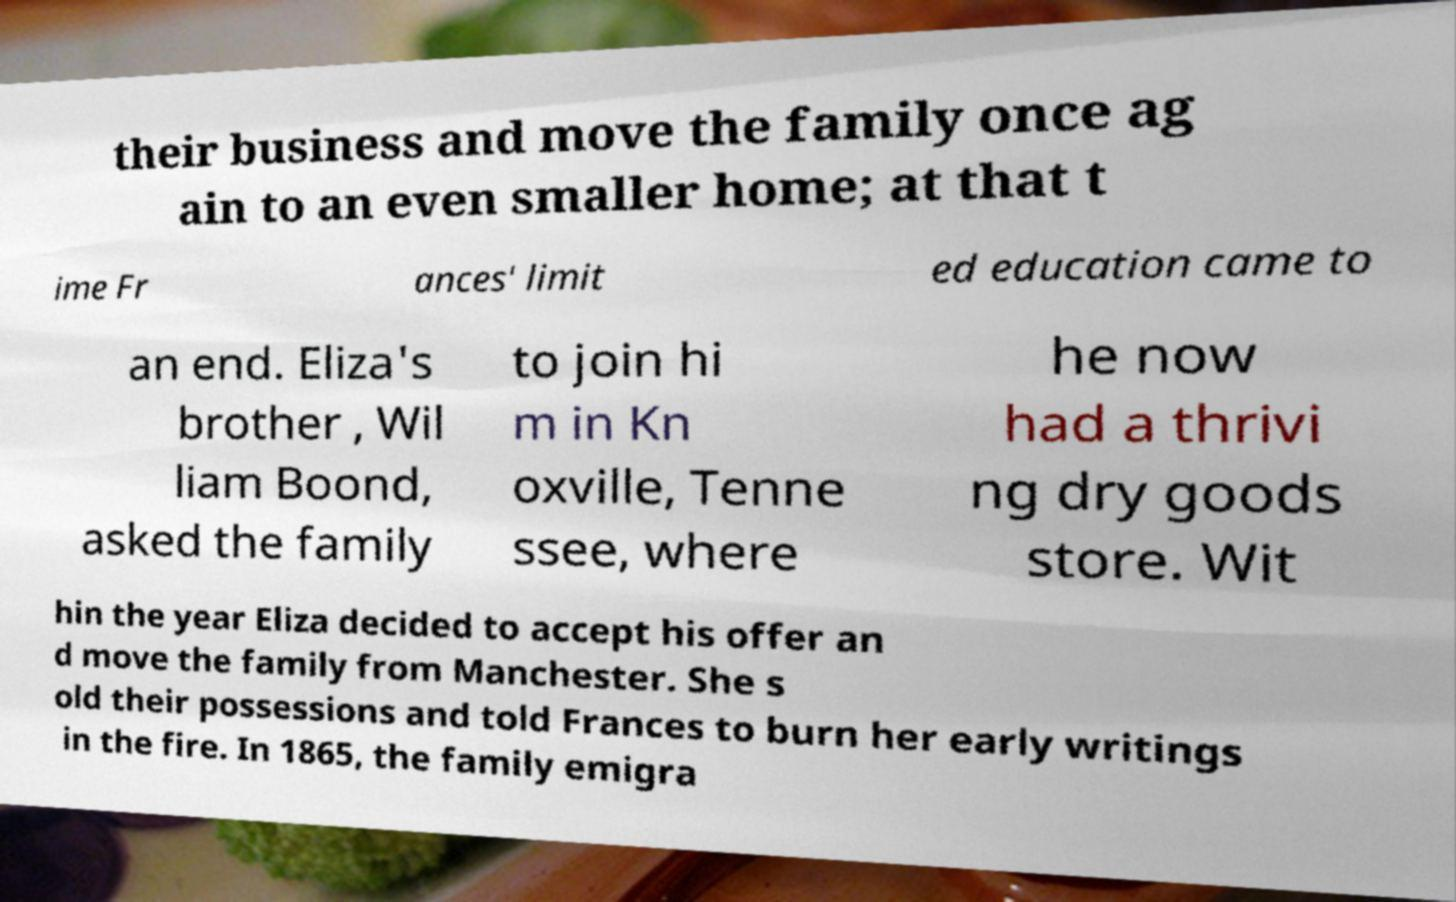Can you accurately transcribe the text from the provided image for me? their business and move the family once ag ain to an even smaller home; at that t ime Fr ances' limit ed education came to an end. Eliza's brother , Wil liam Boond, asked the family to join hi m in Kn oxville, Tenne ssee, where he now had a thrivi ng dry goods store. Wit hin the year Eliza decided to accept his offer an d move the family from Manchester. She s old their possessions and told Frances to burn her early writings in the fire. In 1865, the family emigra 